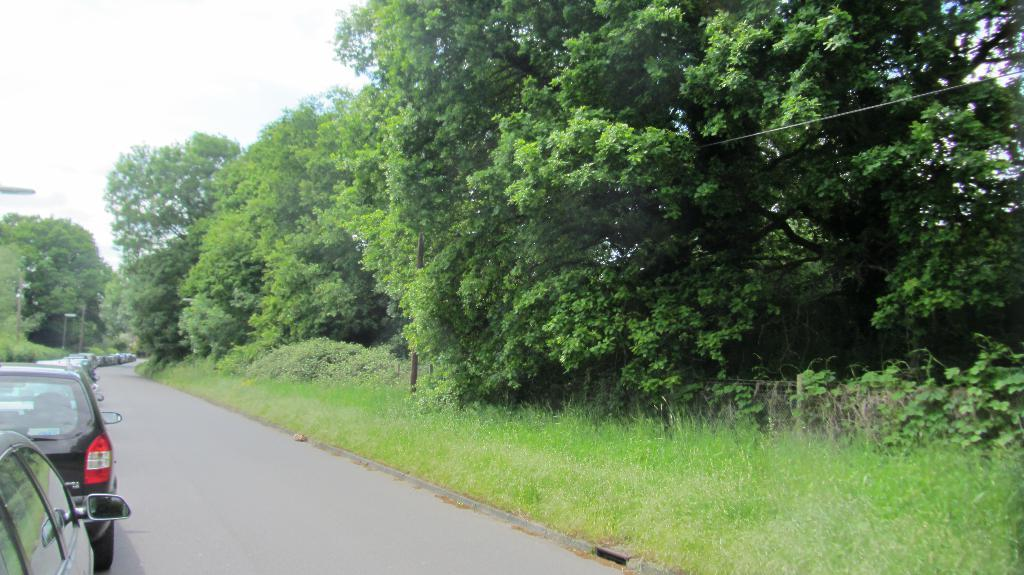What can be seen in the left corner of the image? There are vehicles on the road in the left corner of the image. What is present in the right corner of the image? There is greenery, including grass, and trees in the right corner of the image. Can you tell me how many experts are performing arithmetic calculations on the silk in the image? There is no expert, arithmetic, or silk present in the image. 